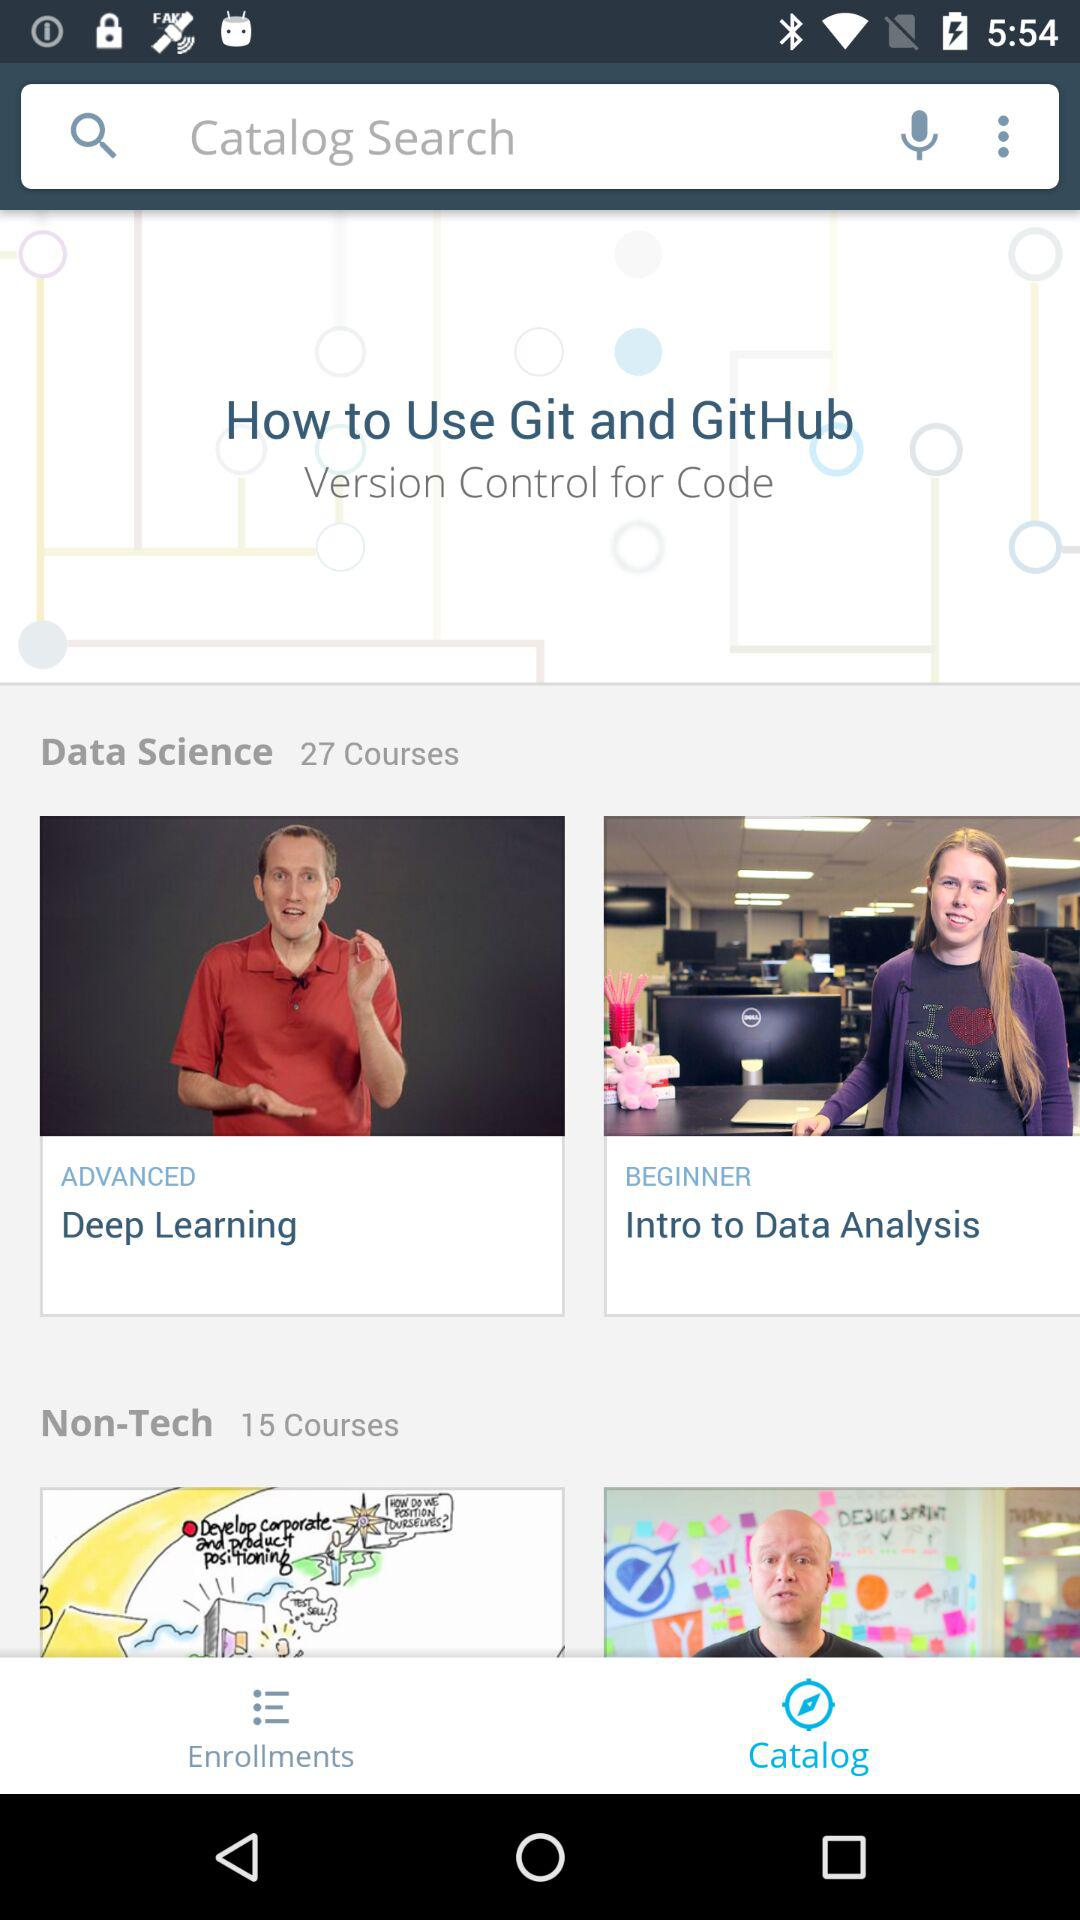Which is the selected tab? The selected tab is "Catalog". 